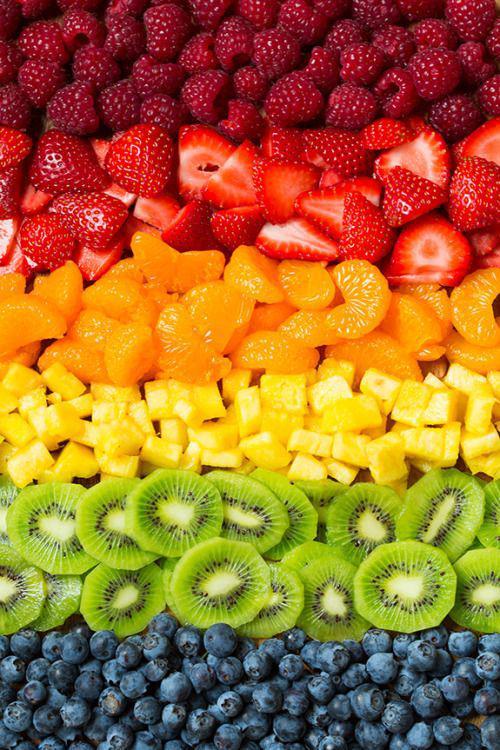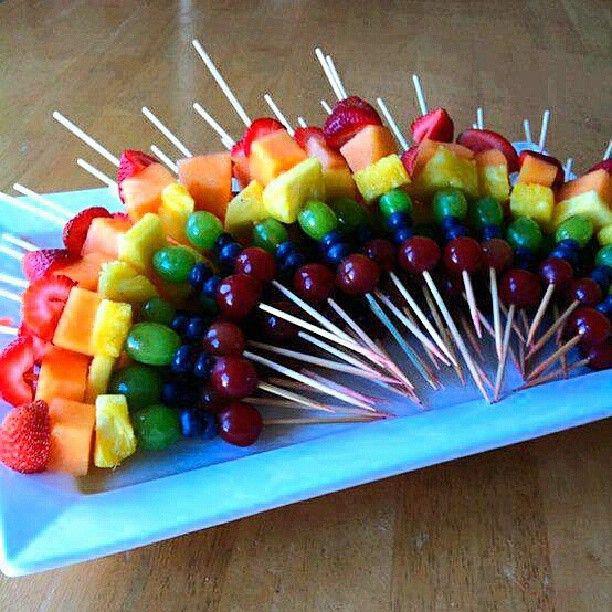The first image is the image on the left, the second image is the image on the right. Analyze the images presented: Is the assertion "Right image shows fruit forming half-circle rainbow shape without use of spears." valid? Answer yes or no. No. 